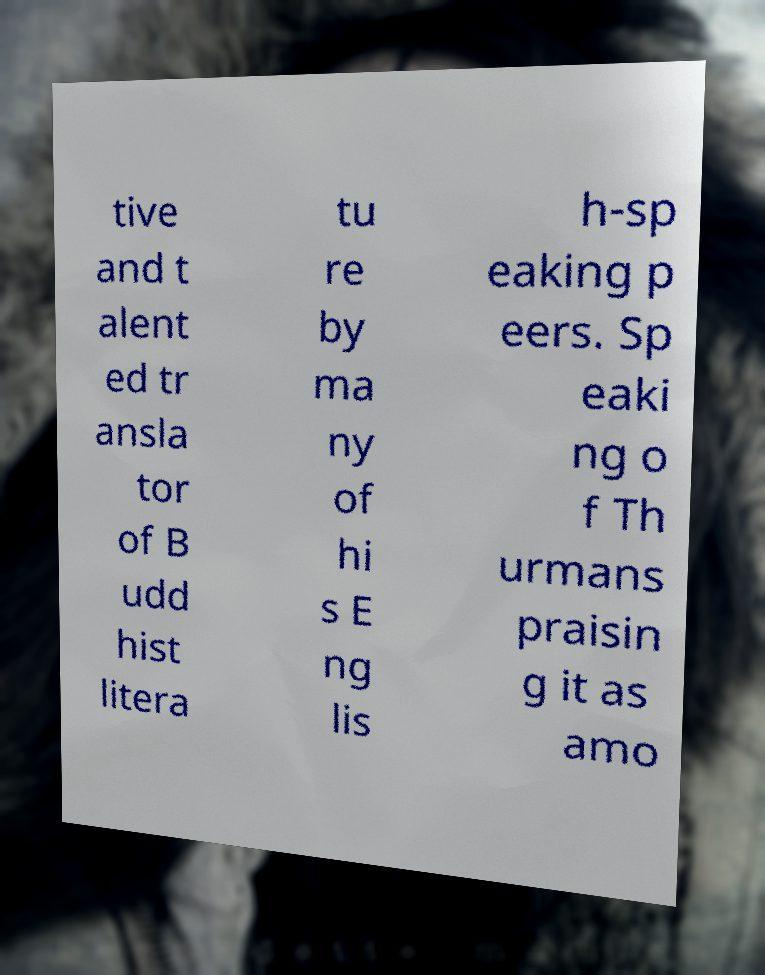There's text embedded in this image that I need extracted. Can you transcribe it verbatim? tive and t alent ed tr ansla tor of B udd hist litera tu re by ma ny of hi s E ng lis h-sp eaking p eers. Sp eaki ng o f Th urmans praisin g it as amo 